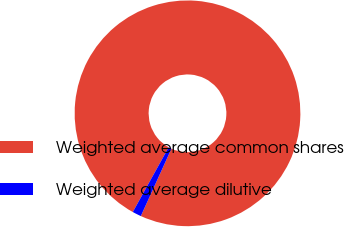Convert chart. <chart><loc_0><loc_0><loc_500><loc_500><pie_chart><fcel>Weighted average common shares<fcel>Weighted average dilutive<nl><fcel>98.73%<fcel>1.27%<nl></chart> 